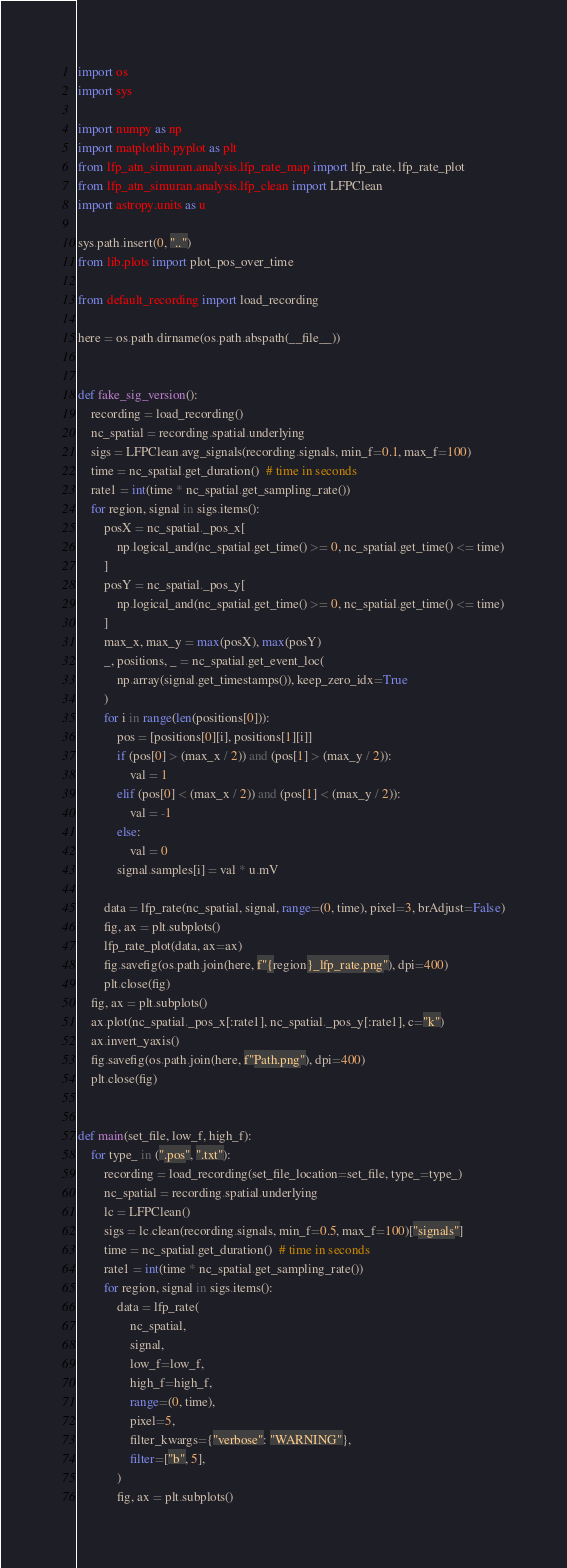Convert code to text. <code><loc_0><loc_0><loc_500><loc_500><_Python_>import os
import sys

import numpy as np
import matplotlib.pyplot as plt
from lfp_atn_simuran.analysis.lfp_rate_map import lfp_rate, lfp_rate_plot
from lfp_atn_simuran.analysis.lfp_clean import LFPClean
import astropy.units as u

sys.path.insert(0, "..")
from lib.plots import plot_pos_over_time

from default_recording import load_recording

here = os.path.dirname(os.path.abspath(__file__))


def fake_sig_version():
    recording = load_recording()
    nc_spatial = recording.spatial.underlying
    sigs = LFPClean.avg_signals(recording.signals, min_f=0.1, max_f=100)
    time = nc_spatial.get_duration()  # time in seconds
    rate1 = int(time * nc_spatial.get_sampling_rate())
    for region, signal in sigs.items():
        posX = nc_spatial._pos_x[
            np.logical_and(nc_spatial.get_time() >= 0, nc_spatial.get_time() <= time)
        ]
        posY = nc_spatial._pos_y[
            np.logical_and(nc_spatial.get_time() >= 0, nc_spatial.get_time() <= time)
        ]
        max_x, max_y = max(posX), max(posY)
        _, positions, _ = nc_spatial.get_event_loc(
            np.array(signal.get_timestamps()), keep_zero_idx=True
        )
        for i in range(len(positions[0])):
            pos = [positions[0][i], positions[1][i]]
            if (pos[0] > (max_x / 2)) and (pos[1] > (max_y / 2)):
                val = 1
            elif (pos[0] < (max_x / 2)) and (pos[1] < (max_y / 2)):
                val = -1
            else:
                val = 0
            signal.samples[i] = val * u.mV

        data = lfp_rate(nc_spatial, signal, range=(0, time), pixel=3, brAdjust=False)
        fig, ax = plt.subplots()
        lfp_rate_plot(data, ax=ax)
        fig.savefig(os.path.join(here, f"{region}_lfp_rate.png"), dpi=400)
        plt.close(fig)
    fig, ax = plt.subplots()
    ax.plot(nc_spatial._pos_x[:rate1], nc_spatial._pos_y[:rate1], c="k")
    ax.invert_yaxis()
    fig.savefig(os.path.join(here, f"Path.png"), dpi=400)
    plt.close(fig)


def main(set_file, low_f, high_f):
    for type_ in (".pos", ".txt"):
        recording = load_recording(set_file_location=set_file, type_=type_)
        nc_spatial = recording.spatial.underlying
        lc = LFPClean()
        sigs = lc.clean(recording.signals, min_f=0.5, max_f=100)["signals"]
        time = nc_spatial.get_duration()  # time in seconds
        rate1 = int(time * nc_spatial.get_sampling_rate())
        for region, signal in sigs.items():
            data = lfp_rate(
                nc_spatial,
                signal,
                low_f=low_f,
                high_f=high_f,
                range=(0, time),
                pixel=5,
                filter_kwargs={"verbose": "WARNING"},
                filter=["b", 5],
            )
            fig, ax = plt.subplots()</code> 